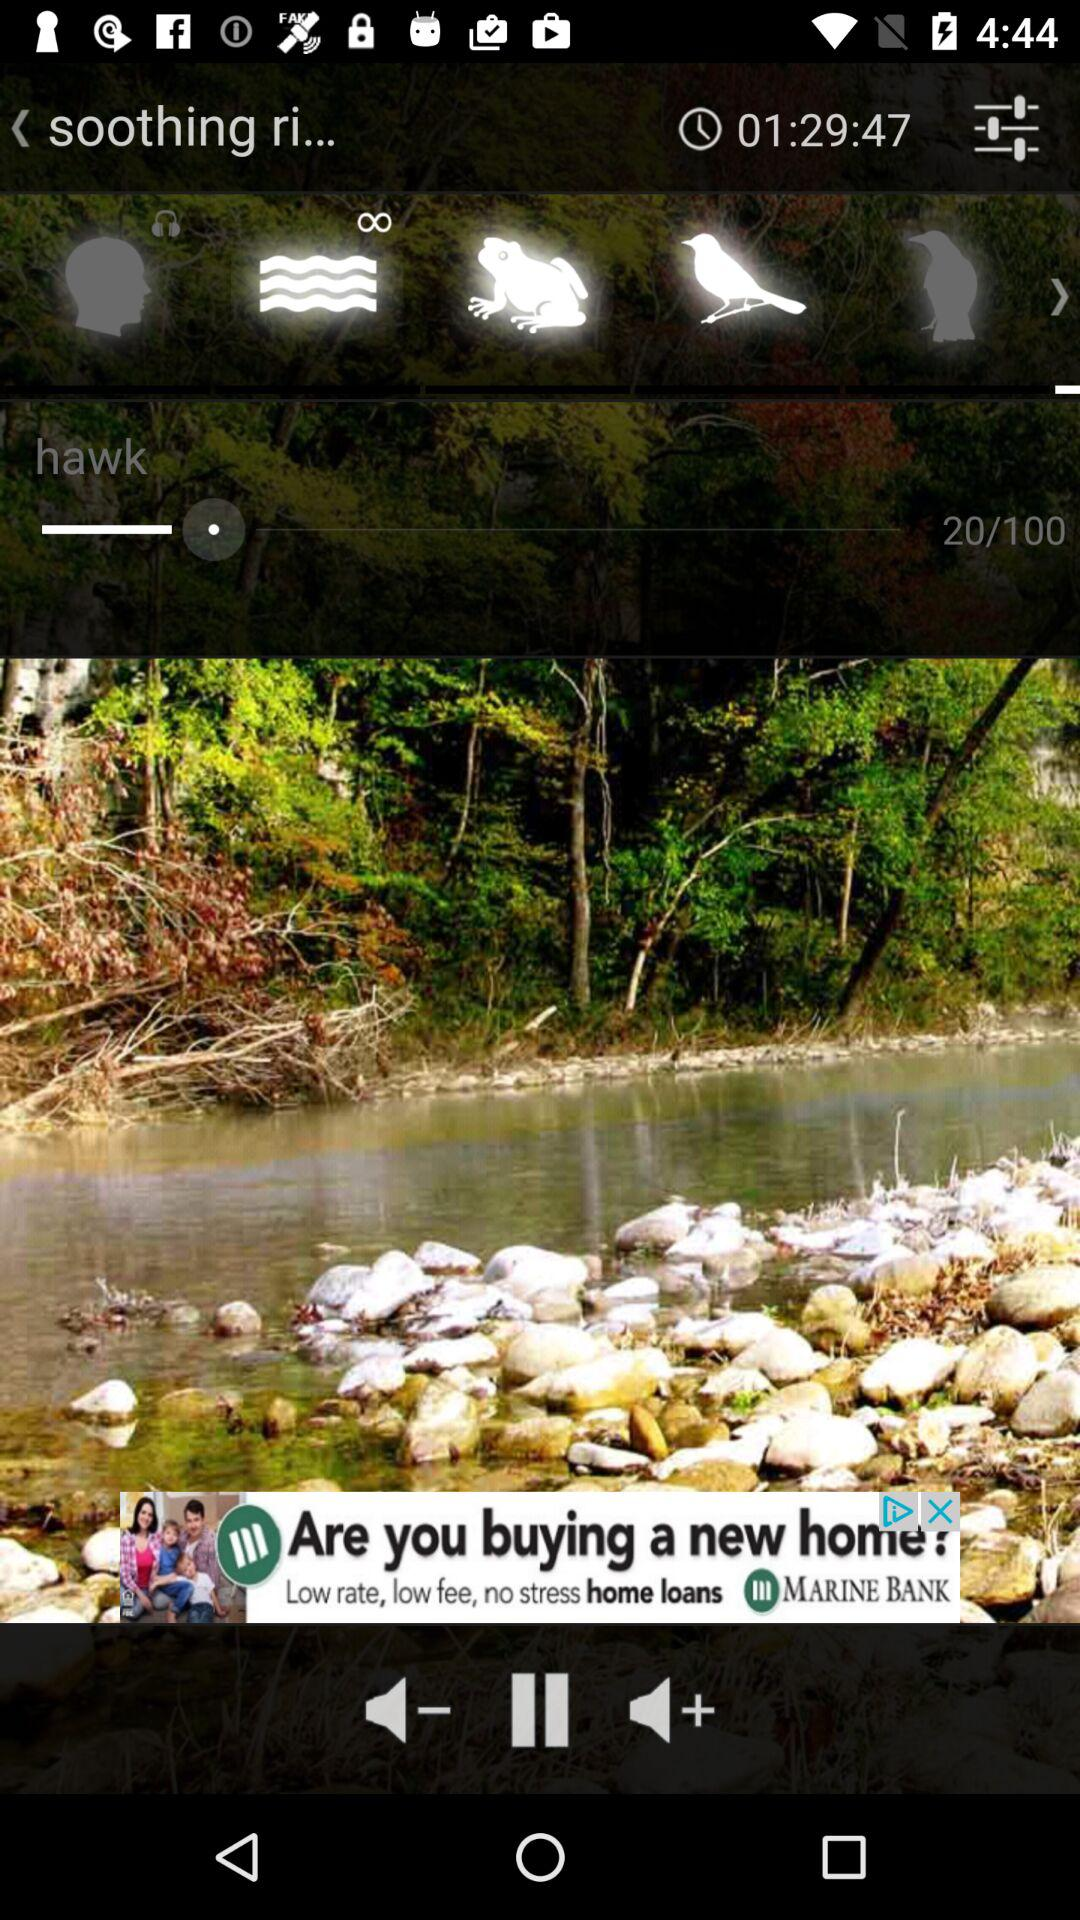How many total pages are there?
When the provided information is insufficient, respond with <no answer>. <no answer> 